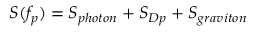Convert formula to latex. <formula><loc_0><loc_0><loc_500><loc_500>S ( f _ { p } ) = S _ { p h o t o n } + S _ { D p } + S _ { g r a v i t o n }</formula> 